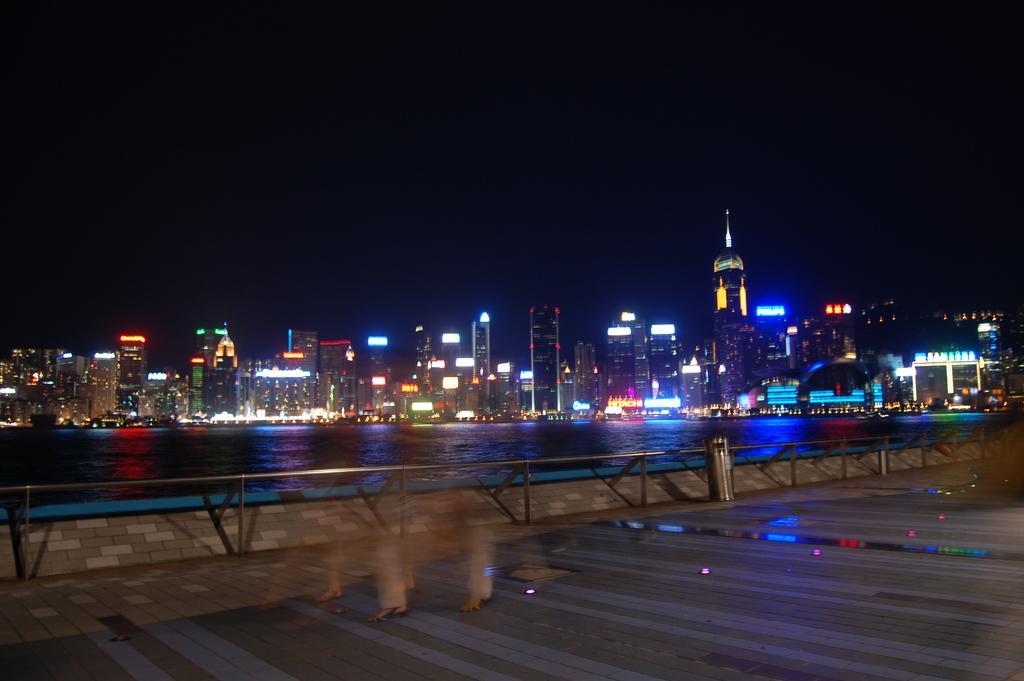Can you describe this image briefly? In the picture we can see a road and beside it, we can see a railing and behind it, we can see water and far away from it, we can see houses and buildings with lights and behind it we can see a sky which is dark. 